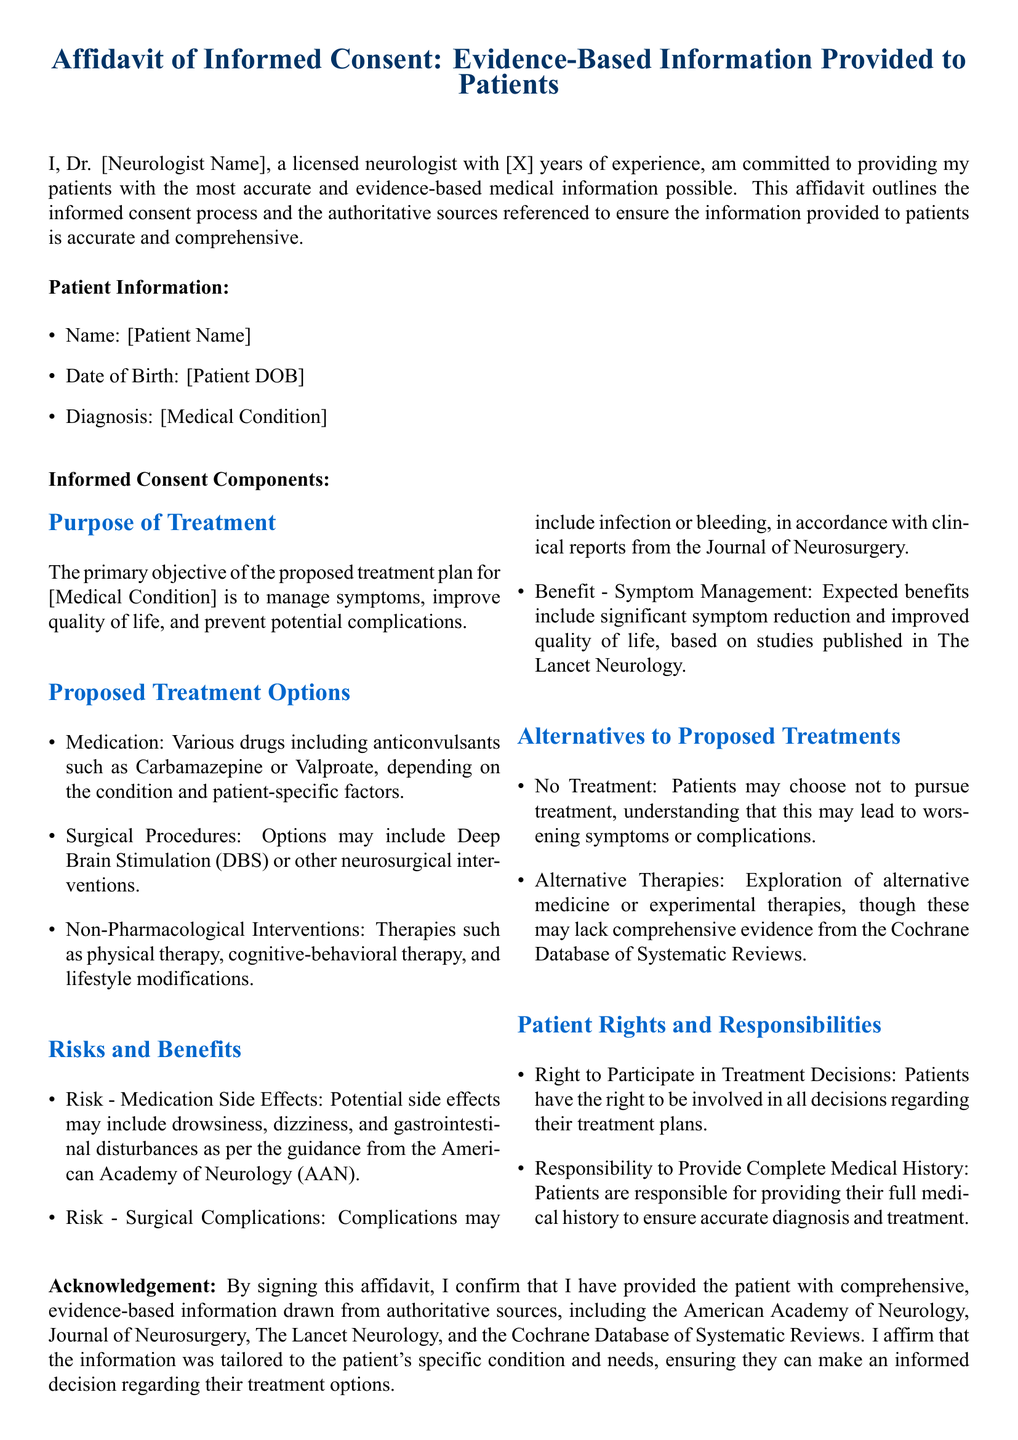What is the name of the neurologist? The neurologist's name is presented as a placeholder in the document (Dr. [Neurologist Name]).
Answer: [Neurologist Name] What is the patient's date of birth? The patient's date of birth is indicated as a placeholder in the document (Date of Birth: [Patient DOB]).
Answer: [Patient DOB] What are the proposed medication options? The document lists various medications including anticonvulsants such as Carbamazepine or Valproate.
Answer: Carbamazepine or Valproate What is one of the rights of the patient according to this affidavit? The document states that patients have the right to participate in treatment decisions as part of their rights and responsibilities.
Answer: Right to Participate in Treatment Decisions What is the primary objective of the proposed treatment plan? The primary objective is to manage symptoms, improve quality of life, and prevent potential complications.
Answer: Manage symptoms, improve quality of life, and prevent potential complications Which authoritative source discusses surgical complications? The document refers to clinical reports from the Journal of Neurosurgery regarding surgical complications.
Answer: Journal of Neurosurgery What are alternative therapies mentioned in the document? Alternative therapies include exploration of alternative medicine or experimental therapies, though they may lack comprehensive evidence.
Answer: Alternative medicine or experimental therapies What number of years of experience does the neurologist have? The years of experience are presented as a placeholder (X) in the document.
Answer: [X] 